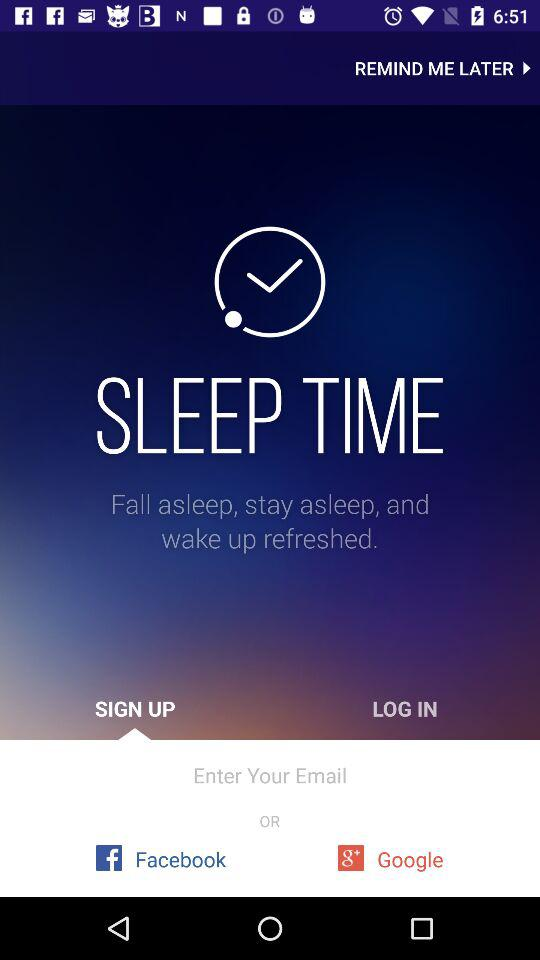What accounts can be used to sign up? The Accounts that can be used to sign up are "Email", "Facebook" and "Google". 